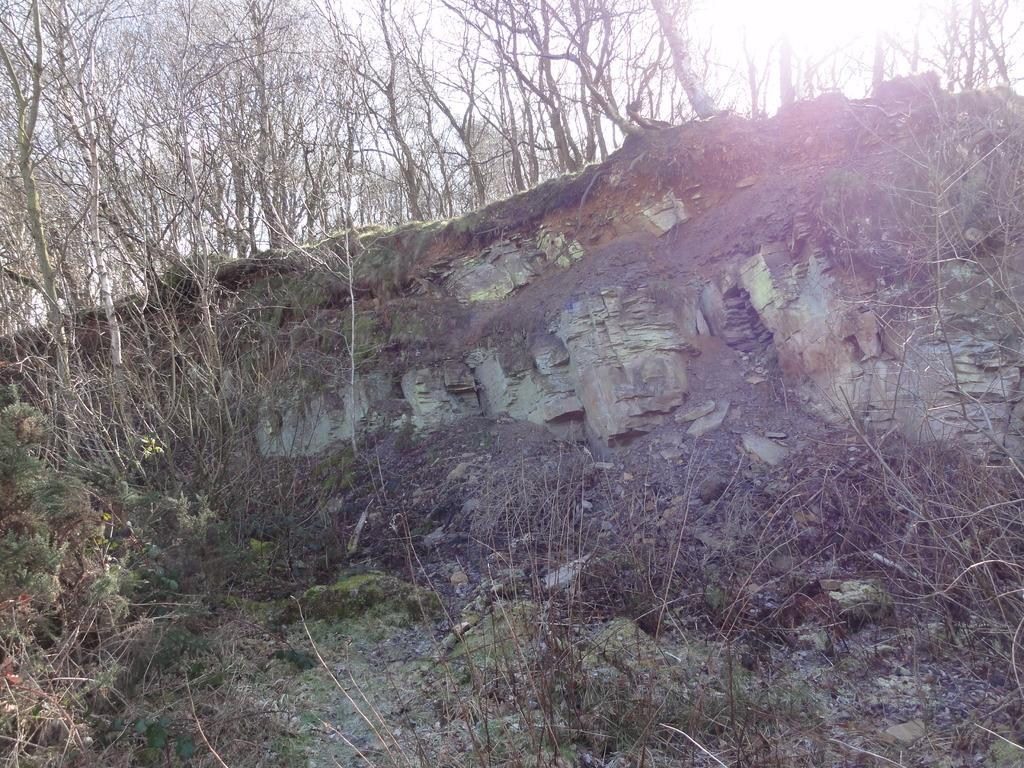What type of setting is depicted in the image? The image is an outside view. What can be seen in the image besides the sky? There are many trees and a hill in the image. What is visible at the top of the image? The sky is visible at the top of the image. What is the source of light in the image? Sunlight is present in the image. What type of tank is visible on the hill in the image? There is no tank present in the image; it features trees, a hill, and the sky. What color is the sweater worn by the carriage driver in the image? There is no carriage or driver present in the image; it features trees, a hill, and the sky. 